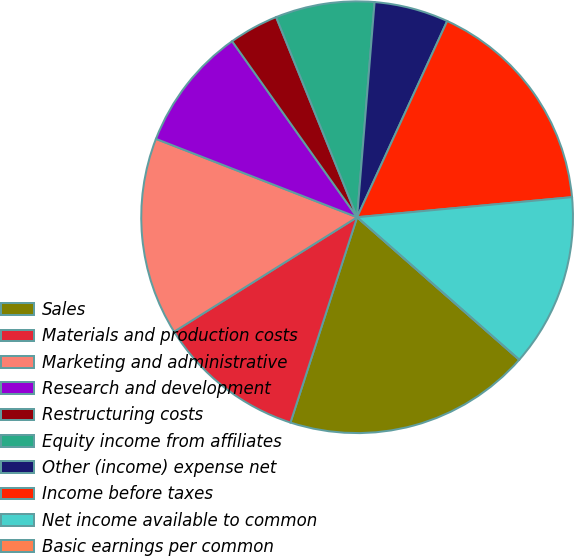<chart> <loc_0><loc_0><loc_500><loc_500><pie_chart><fcel>Sales<fcel>Materials and production costs<fcel>Marketing and administrative<fcel>Research and development<fcel>Restructuring costs<fcel>Equity income from affiliates<fcel>Other (income) expense net<fcel>Income before taxes<fcel>Net income available to common<fcel>Basic earnings per common<nl><fcel>18.52%<fcel>11.11%<fcel>14.81%<fcel>9.26%<fcel>3.71%<fcel>7.41%<fcel>5.56%<fcel>16.67%<fcel>12.96%<fcel>0.0%<nl></chart> 